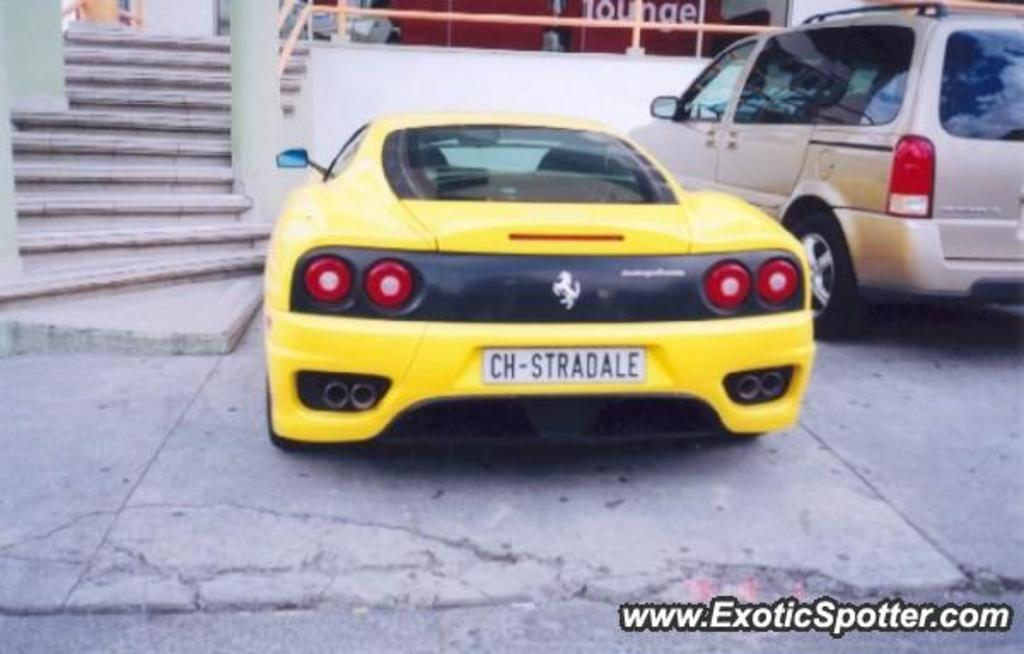What type of structure is visible in the image? There are stairs and a wall visible in the image. What else can be seen in the image besides the stairs and wall? There is a banner and two cars in the image. Can you describe the cars in the image? The car on the right side is white, and the car in the middle is yellow. What type of berry is hanging from the banner in the image? There are no berries present in the image; the banner is the only item mentioned in the facts. 